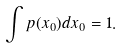Convert formula to latex. <formula><loc_0><loc_0><loc_500><loc_500>\int p ( x _ { 0 } ) d x _ { 0 } = 1 .</formula> 